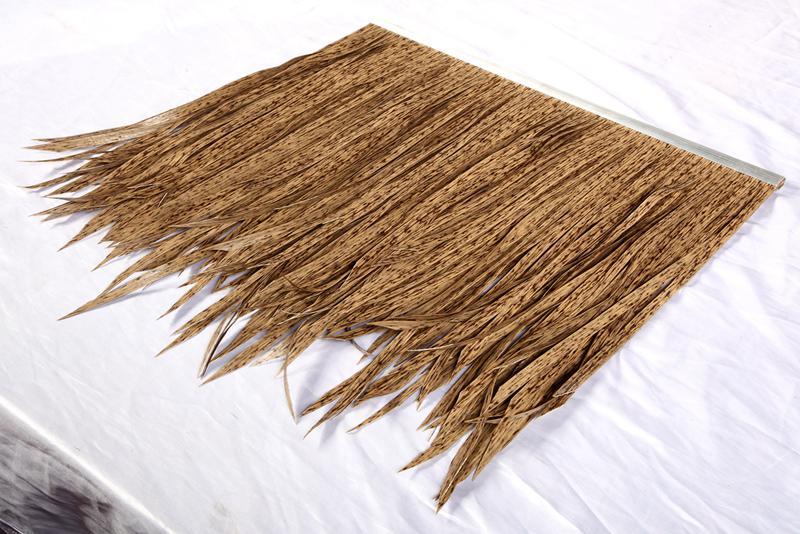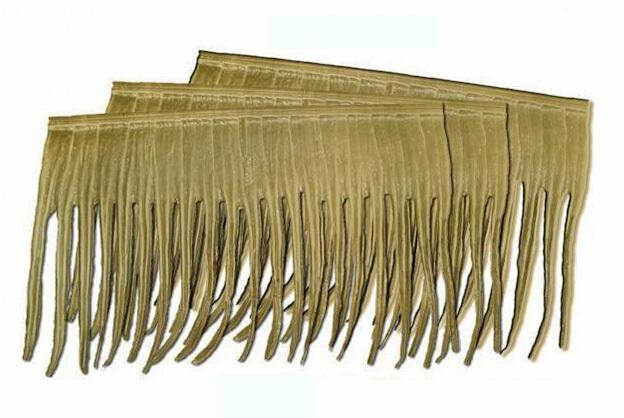The first image is the image on the left, the second image is the image on the right. Given the left and right images, does the statement "An image shows real thatch applied to a flat sloped roof, with something resembling ladder rungs on the right side." hold true? Answer yes or no. No. 